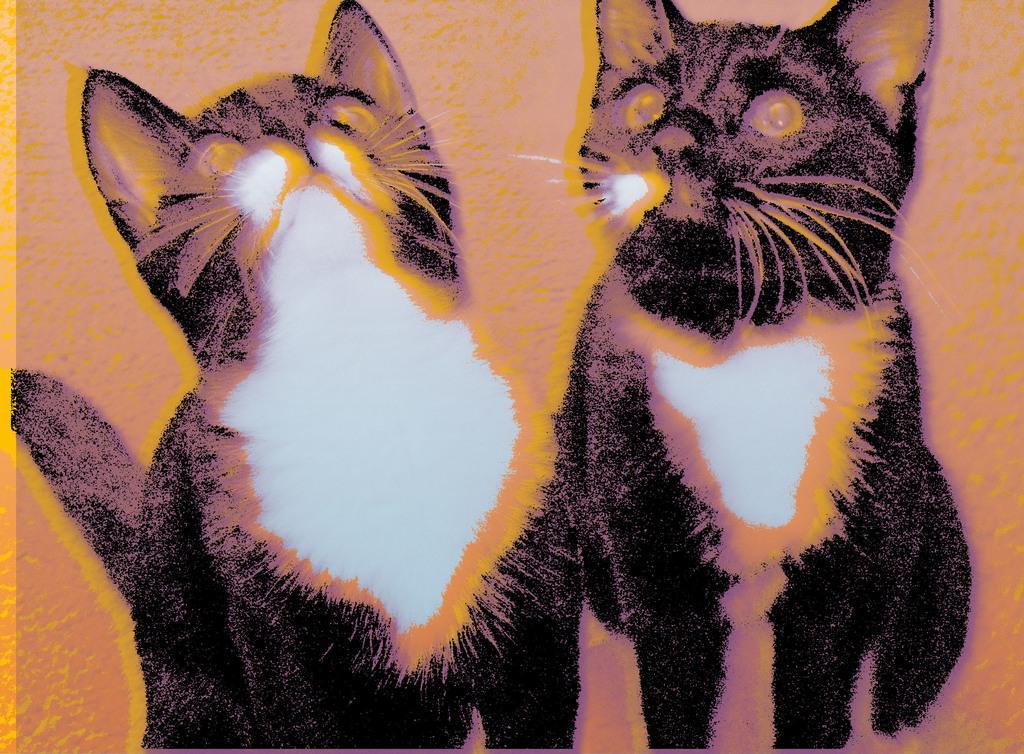In one or two sentences, can you explain what this image depicts? In this image we can see the animated picture of two cats. 